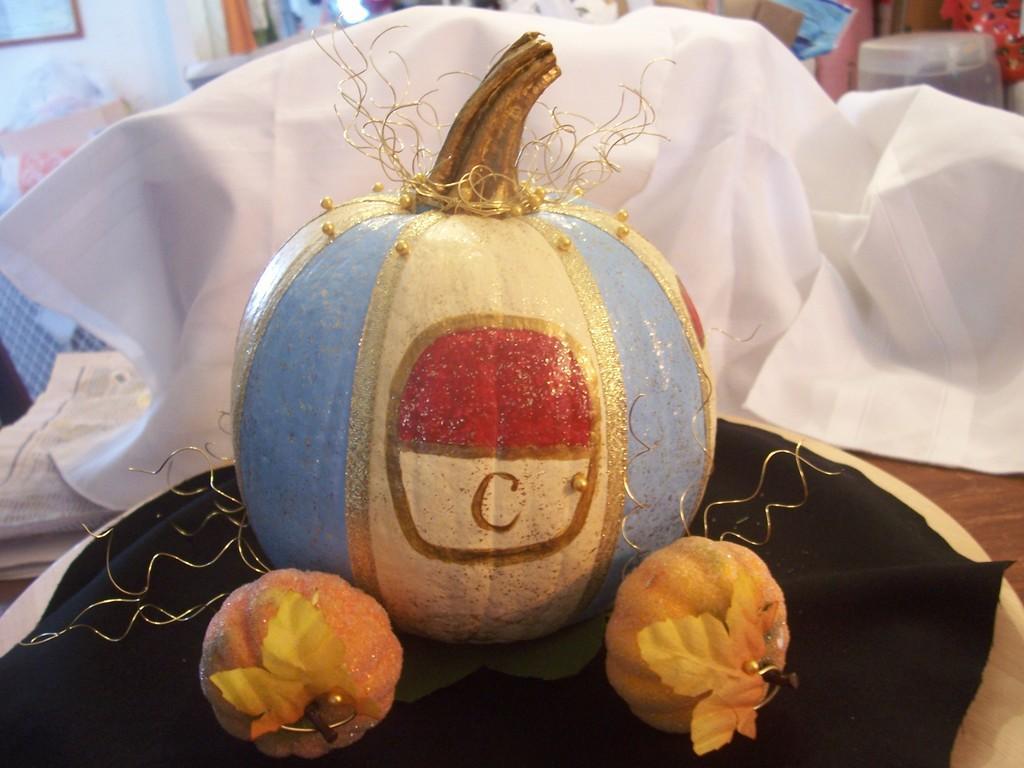Can you describe this image briefly? This is a zoomed in picture. In the center there is a wooden table on the top of which three decorated pumpkins and a white color cloth, a newspaper and some other objects are placed. In the background we can see there are many number of objects. 